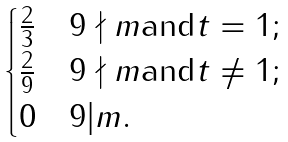Convert formula to latex. <formula><loc_0><loc_0><loc_500><loc_500>\begin{cases} \frac { 2 } { 3 } & 9 \nmid m \text {and} t = 1 ; \\ \frac { 2 } { 9 } & 9 \nmid m \text {and} t \neq 1 ; \\ 0 & 9 | m . \end{cases}</formula> 